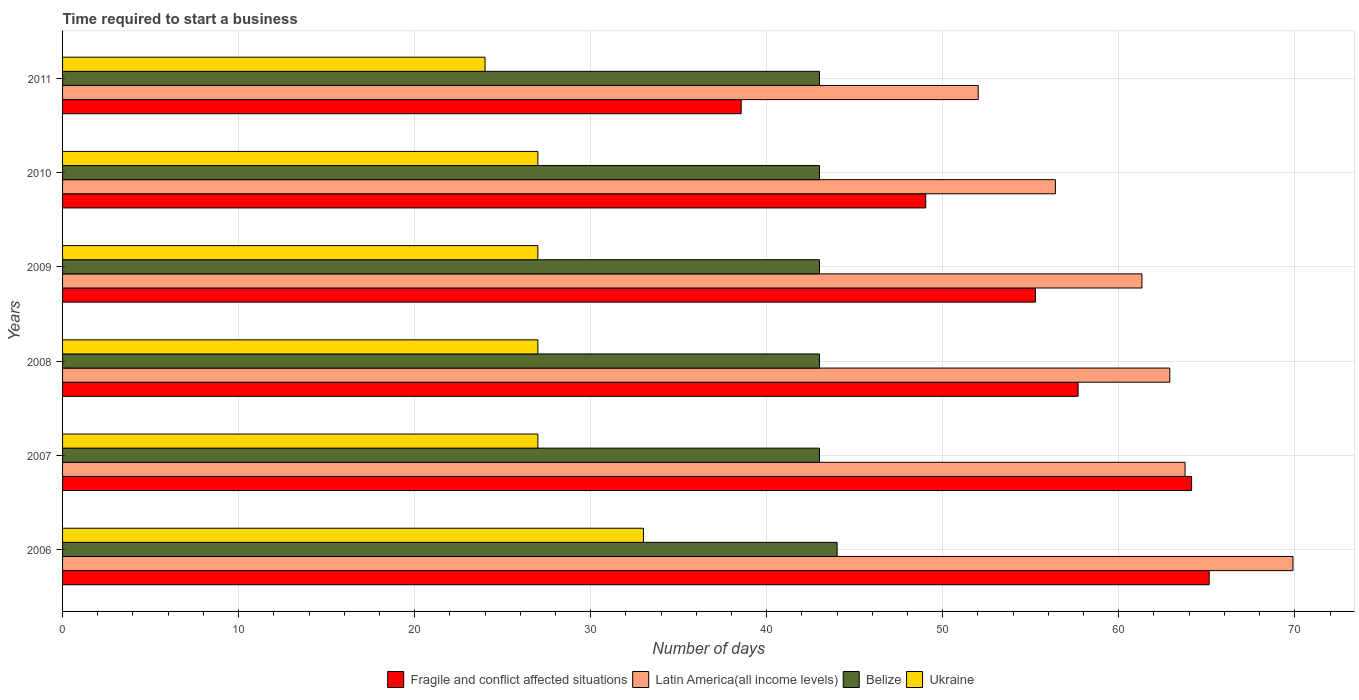How many different coloured bars are there?
Make the answer very short. 4. Are the number of bars per tick equal to the number of legend labels?
Make the answer very short. Yes. How many bars are there on the 1st tick from the bottom?
Make the answer very short. 4. What is the number of days required to start a business in Ukraine in 2007?
Your answer should be very brief. 27. Across all years, what is the minimum number of days required to start a business in Latin America(all income levels)?
Offer a terse response. 52.02. In which year was the number of days required to start a business in Fragile and conflict affected situations maximum?
Give a very brief answer. 2006. In which year was the number of days required to start a business in Fragile and conflict affected situations minimum?
Your answer should be compact. 2011. What is the total number of days required to start a business in Ukraine in the graph?
Offer a very short reply. 165. What is the difference between the number of days required to start a business in Latin America(all income levels) in 2007 and that in 2008?
Keep it short and to the point. 0.87. What is the difference between the number of days required to start a business in Latin America(all income levels) in 2010 and the number of days required to start a business in Ukraine in 2008?
Provide a succinct answer. 29.4. In the year 2007, what is the difference between the number of days required to start a business in Belize and number of days required to start a business in Latin America(all income levels)?
Your response must be concise. -20.77. What is the ratio of the number of days required to start a business in Ukraine in 2006 to that in 2007?
Your answer should be compact. 1.22. Is the difference between the number of days required to start a business in Belize in 2007 and 2009 greater than the difference between the number of days required to start a business in Latin America(all income levels) in 2007 and 2009?
Offer a very short reply. No. What is the difference between the highest and the second highest number of days required to start a business in Latin America(all income levels)?
Give a very brief answer. 6.13. What is the difference between the highest and the lowest number of days required to start a business in Latin America(all income levels)?
Your answer should be very brief. 17.88. In how many years, is the number of days required to start a business in Latin America(all income levels) greater than the average number of days required to start a business in Latin America(all income levels) taken over all years?
Keep it short and to the point. 4. Is it the case that in every year, the sum of the number of days required to start a business in Belize and number of days required to start a business in Fragile and conflict affected situations is greater than the sum of number of days required to start a business in Latin America(all income levels) and number of days required to start a business in Ukraine?
Provide a succinct answer. No. What does the 2nd bar from the top in 2009 represents?
Offer a very short reply. Belize. What does the 3rd bar from the bottom in 2009 represents?
Provide a succinct answer. Belize. Is it the case that in every year, the sum of the number of days required to start a business in Belize and number of days required to start a business in Fragile and conflict affected situations is greater than the number of days required to start a business in Latin America(all income levels)?
Provide a succinct answer. Yes. Are all the bars in the graph horizontal?
Provide a succinct answer. Yes. How many years are there in the graph?
Keep it short and to the point. 6. What is the difference between two consecutive major ticks on the X-axis?
Give a very brief answer. 10. Are the values on the major ticks of X-axis written in scientific E-notation?
Ensure brevity in your answer.  No. Does the graph contain any zero values?
Your answer should be very brief. No. Where does the legend appear in the graph?
Your answer should be compact. Bottom center. How many legend labels are there?
Your answer should be very brief. 4. How are the legend labels stacked?
Your response must be concise. Horizontal. What is the title of the graph?
Provide a succinct answer. Time required to start a business. Does "Fragile and conflict affected situations" appear as one of the legend labels in the graph?
Provide a succinct answer. Yes. What is the label or title of the X-axis?
Make the answer very short. Number of days. What is the label or title of the Y-axis?
Your answer should be compact. Years. What is the Number of days in Fragile and conflict affected situations in 2006?
Offer a very short reply. 65.14. What is the Number of days of Latin America(all income levels) in 2006?
Give a very brief answer. 69.9. What is the Number of days in Fragile and conflict affected situations in 2007?
Your answer should be compact. 64.14. What is the Number of days of Latin America(all income levels) in 2007?
Offer a terse response. 63.77. What is the Number of days of Ukraine in 2007?
Make the answer very short. 27. What is the Number of days of Fragile and conflict affected situations in 2008?
Make the answer very short. 57.69. What is the Number of days in Latin America(all income levels) in 2008?
Provide a succinct answer. 62.9. What is the Number of days in Belize in 2008?
Keep it short and to the point. 43. What is the Number of days of Fragile and conflict affected situations in 2009?
Offer a very short reply. 55.27. What is the Number of days in Latin America(all income levels) in 2009?
Make the answer very short. 61.32. What is the Number of days in Ukraine in 2009?
Give a very brief answer. 27. What is the Number of days of Fragile and conflict affected situations in 2010?
Provide a short and direct response. 49.03. What is the Number of days of Latin America(all income levels) in 2010?
Offer a terse response. 56.4. What is the Number of days of Belize in 2010?
Offer a very short reply. 43. What is the Number of days of Ukraine in 2010?
Make the answer very short. 27. What is the Number of days in Fragile and conflict affected situations in 2011?
Your answer should be compact. 38.55. What is the Number of days in Latin America(all income levels) in 2011?
Provide a succinct answer. 52.02. Across all years, what is the maximum Number of days in Fragile and conflict affected situations?
Provide a succinct answer. 65.14. Across all years, what is the maximum Number of days in Latin America(all income levels)?
Make the answer very short. 69.9. Across all years, what is the maximum Number of days of Belize?
Keep it short and to the point. 44. Across all years, what is the maximum Number of days of Ukraine?
Give a very brief answer. 33. Across all years, what is the minimum Number of days in Fragile and conflict affected situations?
Your response must be concise. 38.55. Across all years, what is the minimum Number of days of Latin America(all income levels)?
Offer a terse response. 52.02. Across all years, what is the minimum Number of days in Belize?
Ensure brevity in your answer.  43. Across all years, what is the minimum Number of days in Ukraine?
Provide a short and direct response. 24. What is the total Number of days in Fragile and conflict affected situations in the graph?
Offer a terse response. 329.82. What is the total Number of days of Latin America(all income levels) in the graph?
Provide a succinct answer. 366.3. What is the total Number of days in Belize in the graph?
Ensure brevity in your answer.  259. What is the total Number of days of Ukraine in the graph?
Ensure brevity in your answer.  165. What is the difference between the Number of days in Fragile and conflict affected situations in 2006 and that in 2007?
Offer a terse response. 1. What is the difference between the Number of days in Latin America(all income levels) in 2006 and that in 2007?
Make the answer very short. 6.13. What is the difference between the Number of days in Belize in 2006 and that in 2007?
Make the answer very short. 1. What is the difference between the Number of days in Fragile and conflict affected situations in 2006 and that in 2008?
Provide a succinct answer. 7.45. What is the difference between the Number of days of Latin America(all income levels) in 2006 and that in 2008?
Ensure brevity in your answer.  7. What is the difference between the Number of days in Ukraine in 2006 and that in 2008?
Give a very brief answer. 6. What is the difference between the Number of days in Fragile and conflict affected situations in 2006 and that in 2009?
Provide a succinct answer. 9.87. What is the difference between the Number of days in Latin America(all income levels) in 2006 and that in 2009?
Your answer should be compact. 8.58. What is the difference between the Number of days in Belize in 2006 and that in 2009?
Your response must be concise. 1. What is the difference between the Number of days of Ukraine in 2006 and that in 2009?
Your answer should be compact. 6. What is the difference between the Number of days in Fragile and conflict affected situations in 2006 and that in 2010?
Offer a very short reply. 16.1. What is the difference between the Number of days in Latin America(all income levels) in 2006 and that in 2010?
Provide a succinct answer. 13.5. What is the difference between the Number of days in Ukraine in 2006 and that in 2010?
Ensure brevity in your answer.  6. What is the difference between the Number of days in Fragile and conflict affected situations in 2006 and that in 2011?
Make the answer very short. 26.59. What is the difference between the Number of days in Latin America(all income levels) in 2006 and that in 2011?
Provide a succinct answer. 17.88. What is the difference between the Number of days in Belize in 2006 and that in 2011?
Give a very brief answer. 1. What is the difference between the Number of days in Fragile and conflict affected situations in 2007 and that in 2008?
Provide a short and direct response. 6.45. What is the difference between the Number of days in Latin America(all income levels) in 2007 and that in 2008?
Provide a succinct answer. 0.87. What is the difference between the Number of days of Belize in 2007 and that in 2008?
Provide a short and direct response. 0. What is the difference between the Number of days of Ukraine in 2007 and that in 2008?
Your answer should be very brief. 0. What is the difference between the Number of days of Fragile and conflict affected situations in 2007 and that in 2009?
Offer a terse response. 8.87. What is the difference between the Number of days of Latin America(all income levels) in 2007 and that in 2009?
Your response must be concise. 2.45. What is the difference between the Number of days of Belize in 2007 and that in 2009?
Offer a terse response. 0. What is the difference between the Number of days in Fragile and conflict affected situations in 2007 and that in 2010?
Provide a succinct answer. 15.1. What is the difference between the Number of days of Latin America(all income levels) in 2007 and that in 2010?
Make the answer very short. 7.37. What is the difference between the Number of days of Fragile and conflict affected situations in 2007 and that in 2011?
Make the answer very short. 25.59. What is the difference between the Number of days in Latin America(all income levels) in 2007 and that in 2011?
Provide a succinct answer. 11.75. What is the difference between the Number of days in Belize in 2007 and that in 2011?
Your answer should be compact. 0. What is the difference between the Number of days of Fragile and conflict affected situations in 2008 and that in 2009?
Give a very brief answer. 2.42. What is the difference between the Number of days of Latin America(all income levels) in 2008 and that in 2009?
Your response must be concise. 1.58. What is the difference between the Number of days in Ukraine in 2008 and that in 2009?
Your answer should be compact. 0. What is the difference between the Number of days in Fragile and conflict affected situations in 2008 and that in 2010?
Your answer should be compact. 8.66. What is the difference between the Number of days of Belize in 2008 and that in 2010?
Your answer should be very brief. 0. What is the difference between the Number of days in Ukraine in 2008 and that in 2010?
Ensure brevity in your answer.  0. What is the difference between the Number of days in Fragile and conflict affected situations in 2008 and that in 2011?
Your response must be concise. 19.14. What is the difference between the Number of days in Latin America(all income levels) in 2008 and that in 2011?
Make the answer very short. 10.88. What is the difference between the Number of days in Belize in 2008 and that in 2011?
Your response must be concise. 0. What is the difference between the Number of days of Ukraine in 2008 and that in 2011?
Ensure brevity in your answer.  3. What is the difference between the Number of days of Fragile and conflict affected situations in 2009 and that in 2010?
Make the answer very short. 6.23. What is the difference between the Number of days of Latin America(all income levels) in 2009 and that in 2010?
Give a very brief answer. 4.92. What is the difference between the Number of days in Belize in 2009 and that in 2010?
Make the answer very short. 0. What is the difference between the Number of days of Ukraine in 2009 and that in 2010?
Provide a succinct answer. 0. What is the difference between the Number of days in Fragile and conflict affected situations in 2009 and that in 2011?
Provide a short and direct response. 16.72. What is the difference between the Number of days of Latin America(all income levels) in 2009 and that in 2011?
Your answer should be compact. 9.3. What is the difference between the Number of days of Ukraine in 2009 and that in 2011?
Give a very brief answer. 3. What is the difference between the Number of days in Fragile and conflict affected situations in 2010 and that in 2011?
Make the answer very short. 10.48. What is the difference between the Number of days in Latin America(all income levels) in 2010 and that in 2011?
Give a very brief answer. 4.38. What is the difference between the Number of days in Belize in 2010 and that in 2011?
Your response must be concise. 0. What is the difference between the Number of days in Ukraine in 2010 and that in 2011?
Offer a very short reply. 3. What is the difference between the Number of days in Fragile and conflict affected situations in 2006 and the Number of days in Latin America(all income levels) in 2007?
Give a very brief answer. 1.37. What is the difference between the Number of days of Fragile and conflict affected situations in 2006 and the Number of days of Belize in 2007?
Give a very brief answer. 22.14. What is the difference between the Number of days of Fragile and conflict affected situations in 2006 and the Number of days of Ukraine in 2007?
Offer a terse response. 38.14. What is the difference between the Number of days of Latin America(all income levels) in 2006 and the Number of days of Belize in 2007?
Your answer should be compact. 26.9. What is the difference between the Number of days in Latin America(all income levels) in 2006 and the Number of days in Ukraine in 2007?
Ensure brevity in your answer.  42.9. What is the difference between the Number of days in Fragile and conflict affected situations in 2006 and the Number of days in Latin America(all income levels) in 2008?
Your response must be concise. 2.24. What is the difference between the Number of days of Fragile and conflict affected situations in 2006 and the Number of days of Belize in 2008?
Provide a succinct answer. 22.14. What is the difference between the Number of days of Fragile and conflict affected situations in 2006 and the Number of days of Ukraine in 2008?
Your answer should be compact. 38.14. What is the difference between the Number of days in Latin America(all income levels) in 2006 and the Number of days in Belize in 2008?
Keep it short and to the point. 26.9. What is the difference between the Number of days of Latin America(all income levels) in 2006 and the Number of days of Ukraine in 2008?
Your response must be concise. 42.9. What is the difference between the Number of days in Fragile and conflict affected situations in 2006 and the Number of days in Latin America(all income levels) in 2009?
Your response must be concise. 3.82. What is the difference between the Number of days of Fragile and conflict affected situations in 2006 and the Number of days of Belize in 2009?
Give a very brief answer. 22.14. What is the difference between the Number of days of Fragile and conflict affected situations in 2006 and the Number of days of Ukraine in 2009?
Ensure brevity in your answer.  38.14. What is the difference between the Number of days in Latin America(all income levels) in 2006 and the Number of days in Belize in 2009?
Give a very brief answer. 26.9. What is the difference between the Number of days in Latin America(all income levels) in 2006 and the Number of days in Ukraine in 2009?
Your answer should be very brief. 42.9. What is the difference between the Number of days in Fragile and conflict affected situations in 2006 and the Number of days in Latin America(all income levels) in 2010?
Offer a terse response. 8.74. What is the difference between the Number of days of Fragile and conflict affected situations in 2006 and the Number of days of Belize in 2010?
Your answer should be compact. 22.14. What is the difference between the Number of days in Fragile and conflict affected situations in 2006 and the Number of days in Ukraine in 2010?
Keep it short and to the point. 38.14. What is the difference between the Number of days in Latin America(all income levels) in 2006 and the Number of days in Belize in 2010?
Provide a succinct answer. 26.9. What is the difference between the Number of days of Latin America(all income levels) in 2006 and the Number of days of Ukraine in 2010?
Your answer should be very brief. 42.9. What is the difference between the Number of days in Belize in 2006 and the Number of days in Ukraine in 2010?
Keep it short and to the point. 17. What is the difference between the Number of days in Fragile and conflict affected situations in 2006 and the Number of days in Latin America(all income levels) in 2011?
Keep it short and to the point. 13.12. What is the difference between the Number of days of Fragile and conflict affected situations in 2006 and the Number of days of Belize in 2011?
Make the answer very short. 22.14. What is the difference between the Number of days in Fragile and conflict affected situations in 2006 and the Number of days in Ukraine in 2011?
Give a very brief answer. 41.14. What is the difference between the Number of days of Latin America(all income levels) in 2006 and the Number of days of Belize in 2011?
Your answer should be compact. 26.9. What is the difference between the Number of days of Latin America(all income levels) in 2006 and the Number of days of Ukraine in 2011?
Your answer should be compact. 45.9. What is the difference between the Number of days of Belize in 2006 and the Number of days of Ukraine in 2011?
Your answer should be compact. 20. What is the difference between the Number of days in Fragile and conflict affected situations in 2007 and the Number of days in Latin America(all income levels) in 2008?
Give a very brief answer. 1.24. What is the difference between the Number of days in Fragile and conflict affected situations in 2007 and the Number of days in Belize in 2008?
Provide a short and direct response. 21.14. What is the difference between the Number of days in Fragile and conflict affected situations in 2007 and the Number of days in Ukraine in 2008?
Your response must be concise. 37.14. What is the difference between the Number of days in Latin America(all income levels) in 2007 and the Number of days in Belize in 2008?
Give a very brief answer. 20.77. What is the difference between the Number of days of Latin America(all income levels) in 2007 and the Number of days of Ukraine in 2008?
Offer a very short reply. 36.77. What is the difference between the Number of days of Fragile and conflict affected situations in 2007 and the Number of days of Latin America(all income levels) in 2009?
Provide a succinct answer. 2.82. What is the difference between the Number of days in Fragile and conflict affected situations in 2007 and the Number of days in Belize in 2009?
Your response must be concise. 21.14. What is the difference between the Number of days of Fragile and conflict affected situations in 2007 and the Number of days of Ukraine in 2009?
Your answer should be compact. 37.14. What is the difference between the Number of days of Latin America(all income levels) in 2007 and the Number of days of Belize in 2009?
Your answer should be very brief. 20.77. What is the difference between the Number of days in Latin America(all income levels) in 2007 and the Number of days in Ukraine in 2009?
Ensure brevity in your answer.  36.77. What is the difference between the Number of days in Fragile and conflict affected situations in 2007 and the Number of days in Latin America(all income levels) in 2010?
Give a very brief answer. 7.74. What is the difference between the Number of days in Fragile and conflict affected situations in 2007 and the Number of days in Belize in 2010?
Your answer should be very brief. 21.14. What is the difference between the Number of days of Fragile and conflict affected situations in 2007 and the Number of days of Ukraine in 2010?
Keep it short and to the point. 37.14. What is the difference between the Number of days of Latin America(all income levels) in 2007 and the Number of days of Belize in 2010?
Provide a succinct answer. 20.77. What is the difference between the Number of days in Latin America(all income levels) in 2007 and the Number of days in Ukraine in 2010?
Provide a short and direct response. 36.77. What is the difference between the Number of days of Belize in 2007 and the Number of days of Ukraine in 2010?
Your answer should be very brief. 16. What is the difference between the Number of days of Fragile and conflict affected situations in 2007 and the Number of days of Latin America(all income levels) in 2011?
Ensure brevity in your answer.  12.12. What is the difference between the Number of days of Fragile and conflict affected situations in 2007 and the Number of days of Belize in 2011?
Your answer should be compact. 21.14. What is the difference between the Number of days of Fragile and conflict affected situations in 2007 and the Number of days of Ukraine in 2011?
Keep it short and to the point. 40.14. What is the difference between the Number of days in Latin America(all income levels) in 2007 and the Number of days in Belize in 2011?
Give a very brief answer. 20.77. What is the difference between the Number of days of Latin America(all income levels) in 2007 and the Number of days of Ukraine in 2011?
Keep it short and to the point. 39.77. What is the difference between the Number of days in Fragile and conflict affected situations in 2008 and the Number of days in Latin America(all income levels) in 2009?
Provide a succinct answer. -3.63. What is the difference between the Number of days of Fragile and conflict affected situations in 2008 and the Number of days of Belize in 2009?
Give a very brief answer. 14.69. What is the difference between the Number of days in Fragile and conflict affected situations in 2008 and the Number of days in Ukraine in 2009?
Give a very brief answer. 30.69. What is the difference between the Number of days of Latin America(all income levels) in 2008 and the Number of days of Ukraine in 2009?
Your answer should be very brief. 35.9. What is the difference between the Number of days in Belize in 2008 and the Number of days in Ukraine in 2009?
Keep it short and to the point. 16. What is the difference between the Number of days of Fragile and conflict affected situations in 2008 and the Number of days of Latin America(all income levels) in 2010?
Your response must be concise. 1.29. What is the difference between the Number of days of Fragile and conflict affected situations in 2008 and the Number of days of Belize in 2010?
Provide a short and direct response. 14.69. What is the difference between the Number of days in Fragile and conflict affected situations in 2008 and the Number of days in Ukraine in 2010?
Make the answer very short. 30.69. What is the difference between the Number of days in Latin America(all income levels) in 2008 and the Number of days in Ukraine in 2010?
Your answer should be very brief. 35.9. What is the difference between the Number of days of Belize in 2008 and the Number of days of Ukraine in 2010?
Keep it short and to the point. 16. What is the difference between the Number of days in Fragile and conflict affected situations in 2008 and the Number of days in Latin America(all income levels) in 2011?
Ensure brevity in your answer.  5.67. What is the difference between the Number of days in Fragile and conflict affected situations in 2008 and the Number of days in Belize in 2011?
Your response must be concise. 14.69. What is the difference between the Number of days of Fragile and conflict affected situations in 2008 and the Number of days of Ukraine in 2011?
Your response must be concise. 33.69. What is the difference between the Number of days of Latin America(all income levels) in 2008 and the Number of days of Belize in 2011?
Your answer should be compact. 19.9. What is the difference between the Number of days of Latin America(all income levels) in 2008 and the Number of days of Ukraine in 2011?
Ensure brevity in your answer.  38.9. What is the difference between the Number of days in Belize in 2008 and the Number of days in Ukraine in 2011?
Offer a very short reply. 19. What is the difference between the Number of days in Fragile and conflict affected situations in 2009 and the Number of days in Latin America(all income levels) in 2010?
Make the answer very short. -1.13. What is the difference between the Number of days of Fragile and conflict affected situations in 2009 and the Number of days of Belize in 2010?
Your answer should be compact. 12.27. What is the difference between the Number of days of Fragile and conflict affected situations in 2009 and the Number of days of Ukraine in 2010?
Your response must be concise. 28.27. What is the difference between the Number of days of Latin America(all income levels) in 2009 and the Number of days of Belize in 2010?
Your answer should be very brief. 18.32. What is the difference between the Number of days of Latin America(all income levels) in 2009 and the Number of days of Ukraine in 2010?
Ensure brevity in your answer.  34.32. What is the difference between the Number of days of Fragile and conflict affected situations in 2009 and the Number of days of Latin America(all income levels) in 2011?
Keep it short and to the point. 3.25. What is the difference between the Number of days in Fragile and conflict affected situations in 2009 and the Number of days in Belize in 2011?
Make the answer very short. 12.27. What is the difference between the Number of days of Fragile and conflict affected situations in 2009 and the Number of days of Ukraine in 2011?
Offer a very short reply. 31.27. What is the difference between the Number of days in Latin America(all income levels) in 2009 and the Number of days in Belize in 2011?
Your answer should be compact. 18.32. What is the difference between the Number of days in Latin America(all income levels) in 2009 and the Number of days in Ukraine in 2011?
Give a very brief answer. 37.32. What is the difference between the Number of days of Fragile and conflict affected situations in 2010 and the Number of days of Latin America(all income levels) in 2011?
Make the answer very short. -2.98. What is the difference between the Number of days in Fragile and conflict affected situations in 2010 and the Number of days in Belize in 2011?
Provide a short and direct response. 6.03. What is the difference between the Number of days of Fragile and conflict affected situations in 2010 and the Number of days of Ukraine in 2011?
Your response must be concise. 25.03. What is the difference between the Number of days in Latin America(all income levels) in 2010 and the Number of days in Belize in 2011?
Give a very brief answer. 13.4. What is the difference between the Number of days of Latin America(all income levels) in 2010 and the Number of days of Ukraine in 2011?
Keep it short and to the point. 32.4. What is the difference between the Number of days in Belize in 2010 and the Number of days in Ukraine in 2011?
Give a very brief answer. 19. What is the average Number of days of Fragile and conflict affected situations per year?
Ensure brevity in your answer.  54.97. What is the average Number of days of Latin America(all income levels) per year?
Give a very brief answer. 61.05. What is the average Number of days in Belize per year?
Offer a very short reply. 43.17. In the year 2006, what is the difference between the Number of days in Fragile and conflict affected situations and Number of days in Latin America(all income levels)?
Give a very brief answer. -4.76. In the year 2006, what is the difference between the Number of days of Fragile and conflict affected situations and Number of days of Belize?
Ensure brevity in your answer.  21.14. In the year 2006, what is the difference between the Number of days of Fragile and conflict affected situations and Number of days of Ukraine?
Offer a terse response. 32.14. In the year 2006, what is the difference between the Number of days in Latin America(all income levels) and Number of days in Belize?
Your answer should be compact. 25.9. In the year 2006, what is the difference between the Number of days of Latin America(all income levels) and Number of days of Ukraine?
Offer a very short reply. 36.9. In the year 2007, what is the difference between the Number of days of Fragile and conflict affected situations and Number of days of Latin America(all income levels)?
Make the answer very short. 0.37. In the year 2007, what is the difference between the Number of days of Fragile and conflict affected situations and Number of days of Belize?
Give a very brief answer. 21.14. In the year 2007, what is the difference between the Number of days in Fragile and conflict affected situations and Number of days in Ukraine?
Your answer should be compact. 37.14. In the year 2007, what is the difference between the Number of days of Latin America(all income levels) and Number of days of Belize?
Ensure brevity in your answer.  20.77. In the year 2007, what is the difference between the Number of days of Latin America(all income levels) and Number of days of Ukraine?
Offer a terse response. 36.77. In the year 2008, what is the difference between the Number of days in Fragile and conflict affected situations and Number of days in Latin America(all income levels)?
Your response must be concise. -5.21. In the year 2008, what is the difference between the Number of days in Fragile and conflict affected situations and Number of days in Belize?
Provide a succinct answer. 14.69. In the year 2008, what is the difference between the Number of days of Fragile and conflict affected situations and Number of days of Ukraine?
Your response must be concise. 30.69. In the year 2008, what is the difference between the Number of days of Latin America(all income levels) and Number of days of Belize?
Provide a short and direct response. 19.9. In the year 2008, what is the difference between the Number of days in Latin America(all income levels) and Number of days in Ukraine?
Ensure brevity in your answer.  35.9. In the year 2008, what is the difference between the Number of days of Belize and Number of days of Ukraine?
Offer a terse response. 16. In the year 2009, what is the difference between the Number of days in Fragile and conflict affected situations and Number of days in Latin America(all income levels)?
Your response must be concise. -6.05. In the year 2009, what is the difference between the Number of days in Fragile and conflict affected situations and Number of days in Belize?
Ensure brevity in your answer.  12.27. In the year 2009, what is the difference between the Number of days of Fragile and conflict affected situations and Number of days of Ukraine?
Ensure brevity in your answer.  28.27. In the year 2009, what is the difference between the Number of days in Latin America(all income levels) and Number of days in Belize?
Ensure brevity in your answer.  18.32. In the year 2009, what is the difference between the Number of days in Latin America(all income levels) and Number of days in Ukraine?
Offer a very short reply. 34.32. In the year 2010, what is the difference between the Number of days in Fragile and conflict affected situations and Number of days in Latin America(all income levels)?
Provide a short and direct response. -7.37. In the year 2010, what is the difference between the Number of days in Fragile and conflict affected situations and Number of days in Belize?
Offer a very short reply. 6.03. In the year 2010, what is the difference between the Number of days in Fragile and conflict affected situations and Number of days in Ukraine?
Keep it short and to the point. 22.03. In the year 2010, what is the difference between the Number of days of Latin America(all income levels) and Number of days of Ukraine?
Ensure brevity in your answer.  29.4. In the year 2011, what is the difference between the Number of days of Fragile and conflict affected situations and Number of days of Latin America(all income levels)?
Make the answer very short. -13.47. In the year 2011, what is the difference between the Number of days in Fragile and conflict affected situations and Number of days in Belize?
Your response must be concise. -4.45. In the year 2011, what is the difference between the Number of days in Fragile and conflict affected situations and Number of days in Ukraine?
Ensure brevity in your answer.  14.55. In the year 2011, what is the difference between the Number of days in Latin America(all income levels) and Number of days in Belize?
Ensure brevity in your answer.  9.02. In the year 2011, what is the difference between the Number of days in Latin America(all income levels) and Number of days in Ukraine?
Your answer should be very brief. 28.02. In the year 2011, what is the difference between the Number of days in Belize and Number of days in Ukraine?
Offer a terse response. 19. What is the ratio of the Number of days of Fragile and conflict affected situations in 2006 to that in 2007?
Offer a terse response. 1.02. What is the ratio of the Number of days of Latin America(all income levels) in 2006 to that in 2007?
Give a very brief answer. 1.1. What is the ratio of the Number of days of Belize in 2006 to that in 2007?
Provide a short and direct response. 1.02. What is the ratio of the Number of days of Ukraine in 2006 to that in 2007?
Make the answer very short. 1.22. What is the ratio of the Number of days in Fragile and conflict affected situations in 2006 to that in 2008?
Provide a short and direct response. 1.13. What is the ratio of the Number of days of Latin America(all income levels) in 2006 to that in 2008?
Offer a terse response. 1.11. What is the ratio of the Number of days of Belize in 2006 to that in 2008?
Provide a short and direct response. 1.02. What is the ratio of the Number of days in Ukraine in 2006 to that in 2008?
Your answer should be very brief. 1.22. What is the ratio of the Number of days in Fragile and conflict affected situations in 2006 to that in 2009?
Your response must be concise. 1.18. What is the ratio of the Number of days in Latin America(all income levels) in 2006 to that in 2009?
Your answer should be very brief. 1.14. What is the ratio of the Number of days of Belize in 2006 to that in 2009?
Offer a terse response. 1.02. What is the ratio of the Number of days in Ukraine in 2006 to that in 2009?
Your response must be concise. 1.22. What is the ratio of the Number of days of Fragile and conflict affected situations in 2006 to that in 2010?
Your response must be concise. 1.33. What is the ratio of the Number of days of Latin America(all income levels) in 2006 to that in 2010?
Keep it short and to the point. 1.24. What is the ratio of the Number of days of Belize in 2006 to that in 2010?
Provide a short and direct response. 1.02. What is the ratio of the Number of days in Ukraine in 2006 to that in 2010?
Give a very brief answer. 1.22. What is the ratio of the Number of days of Fragile and conflict affected situations in 2006 to that in 2011?
Offer a very short reply. 1.69. What is the ratio of the Number of days in Latin America(all income levels) in 2006 to that in 2011?
Offer a very short reply. 1.34. What is the ratio of the Number of days of Belize in 2006 to that in 2011?
Your answer should be compact. 1.02. What is the ratio of the Number of days in Ukraine in 2006 to that in 2011?
Provide a succinct answer. 1.38. What is the ratio of the Number of days of Fragile and conflict affected situations in 2007 to that in 2008?
Provide a succinct answer. 1.11. What is the ratio of the Number of days of Latin America(all income levels) in 2007 to that in 2008?
Ensure brevity in your answer.  1.01. What is the ratio of the Number of days in Fragile and conflict affected situations in 2007 to that in 2009?
Give a very brief answer. 1.16. What is the ratio of the Number of days of Belize in 2007 to that in 2009?
Your response must be concise. 1. What is the ratio of the Number of days of Ukraine in 2007 to that in 2009?
Keep it short and to the point. 1. What is the ratio of the Number of days of Fragile and conflict affected situations in 2007 to that in 2010?
Ensure brevity in your answer.  1.31. What is the ratio of the Number of days in Latin America(all income levels) in 2007 to that in 2010?
Provide a short and direct response. 1.13. What is the ratio of the Number of days in Ukraine in 2007 to that in 2010?
Provide a short and direct response. 1. What is the ratio of the Number of days in Fragile and conflict affected situations in 2007 to that in 2011?
Your response must be concise. 1.66. What is the ratio of the Number of days in Latin America(all income levels) in 2007 to that in 2011?
Give a very brief answer. 1.23. What is the ratio of the Number of days of Belize in 2007 to that in 2011?
Your response must be concise. 1. What is the ratio of the Number of days in Ukraine in 2007 to that in 2011?
Give a very brief answer. 1.12. What is the ratio of the Number of days in Fragile and conflict affected situations in 2008 to that in 2009?
Make the answer very short. 1.04. What is the ratio of the Number of days in Latin America(all income levels) in 2008 to that in 2009?
Your response must be concise. 1.03. What is the ratio of the Number of days in Belize in 2008 to that in 2009?
Keep it short and to the point. 1. What is the ratio of the Number of days of Ukraine in 2008 to that in 2009?
Give a very brief answer. 1. What is the ratio of the Number of days of Fragile and conflict affected situations in 2008 to that in 2010?
Your answer should be very brief. 1.18. What is the ratio of the Number of days in Latin America(all income levels) in 2008 to that in 2010?
Your response must be concise. 1.12. What is the ratio of the Number of days of Fragile and conflict affected situations in 2008 to that in 2011?
Ensure brevity in your answer.  1.5. What is the ratio of the Number of days in Latin America(all income levels) in 2008 to that in 2011?
Provide a succinct answer. 1.21. What is the ratio of the Number of days in Ukraine in 2008 to that in 2011?
Provide a short and direct response. 1.12. What is the ratio of the Number of days in Fragile and conflict affected situations in 2009 to that in 2010?
Make the answer very short. 1.13. What is the ratio of the Number of days of Latin America(all income levels) in 2009 to that in 2010?
Give a very brief answer. 1.09. What is the ratio of the Number of days of Fragile and conflict affected situations in 2009 to that in 2011?
Make the answer very short. 1.43. What is the ratio of the Number of days of Latin America(all income levels) in 2009 to that in 2011?
Your response must be concise. 1.18. What is the ratio of the Number of days of Belize in 2009 to that in 2011?
Offer a very short reply. 1. What is the ratio of the Number of days of Ukraine in 2009 to that in 2011?
Your answer should be very brief. 1.12. What is the ratio of the Number of days of Fragile and conflict affected situations in 2010 to that in 2011?
Your answer should be compact. 1.27. What is the ratio of the Number of days of Latin America(all income levels) in 2010 to that in 2011?
Your response must be concise. 1.08. What is the ratio of the Number of days in Belize in 2010 to that in 2011?
Your answer should be compact. 1. What is the difference between the highest and the second highest Number of days in Fragile and conflict affected situations?
Provide a short and direct response. 1. What is the difference between the highest and the second highest Number of days of Latin America(all income levels)?
Your answer should be compact. 6.13. What is the difference between the highest and the second highest Number of days of Belize?
Keep it short and to the point. 1. What is the difference between the highest and the second highest Number of days of Ukraine?
Provide a short and direct response. 6. What is the difference between the highest and the lowest Number of days of Fragile and conflict affected situations?
Your answer should be compact. 26.59. What is the difference between the highest and the lowest Number of days of Latin America(all income levels)?
Provide a succinct answer. 17.88. What is the difference between the highest and the lowest Number of days of Belize?
Your answer should be compact. 1. 